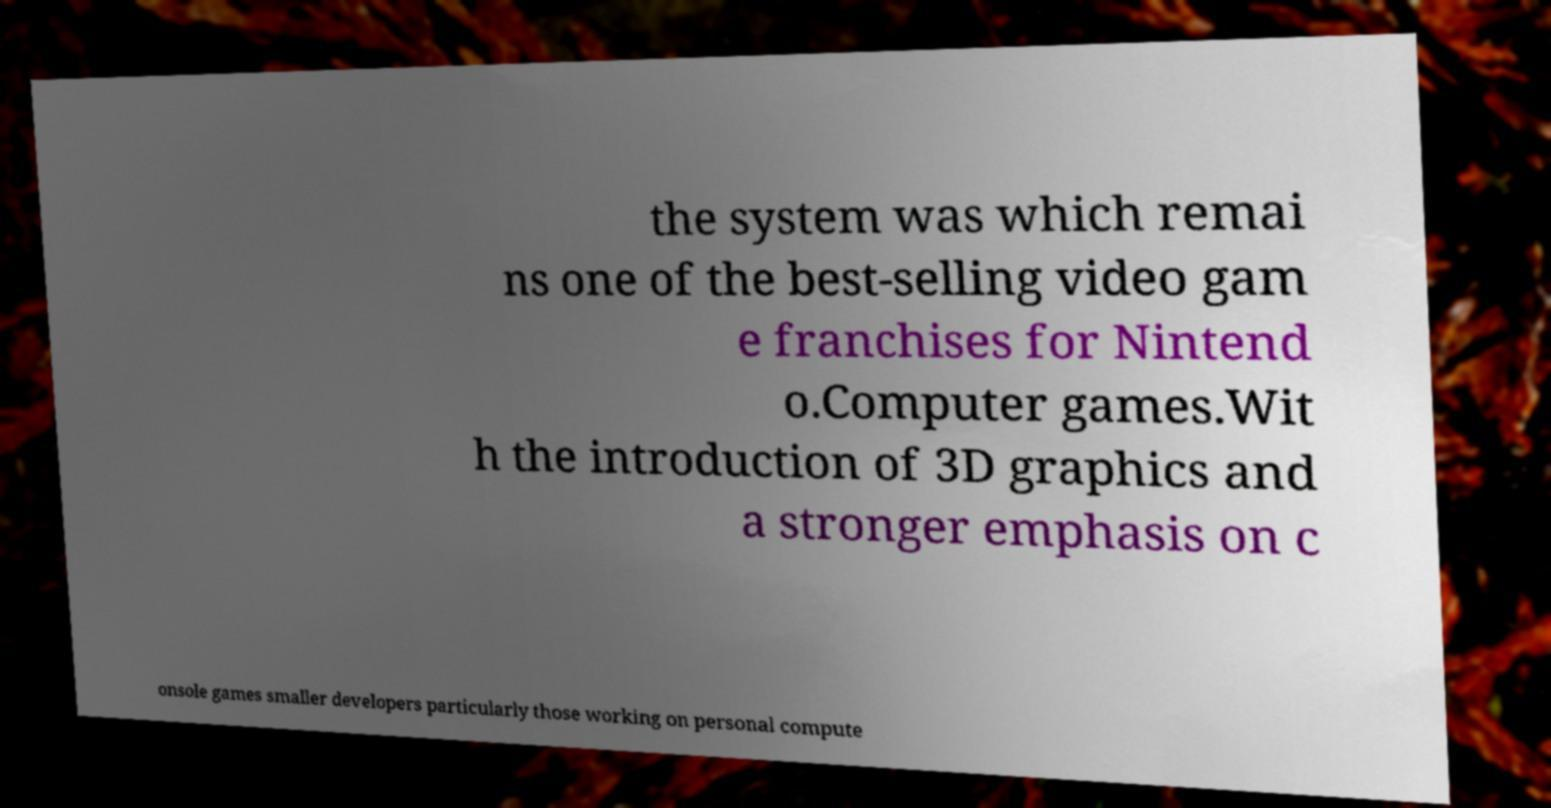Could you assist in decoding the text presented in this image and type it out clearly? the system was which remai ns one of the best-selling video gam e franchises for Nintend o.Computer games.Wit h the introduction of 3D graphics and a stronger emphasis on c onsole games smaller developers particularly those working on personal compute 